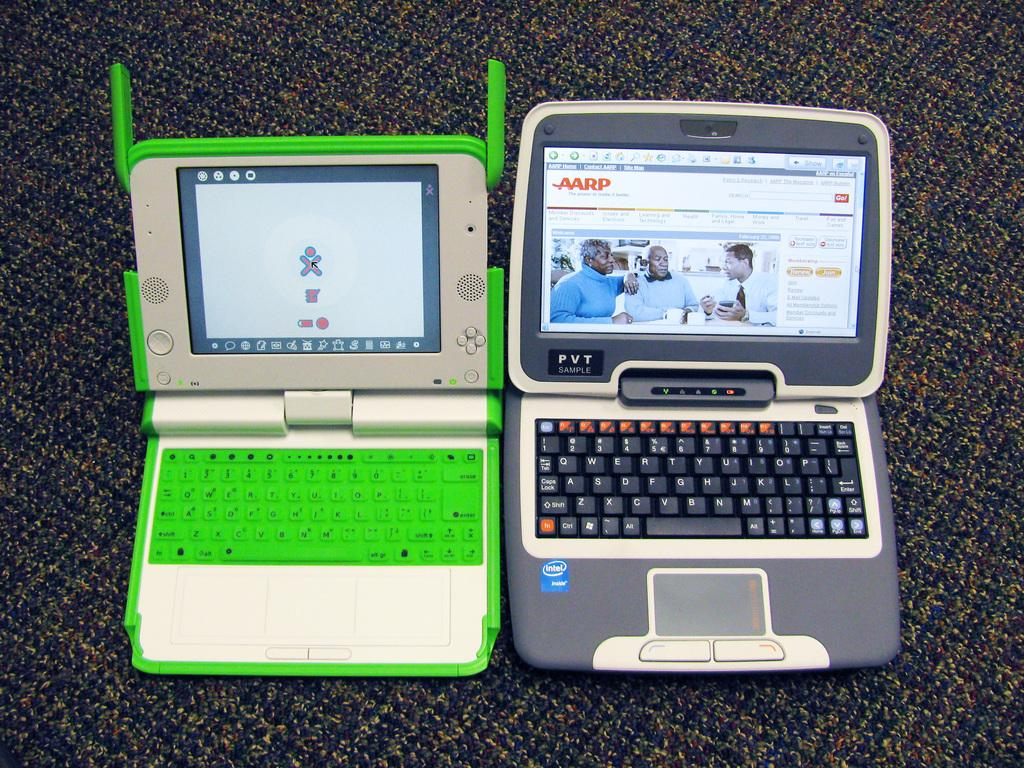<image>
Offer a succinct explanation of the picture presented. Two laptops side by side; the one on the right has the letters AARP on the screen. 